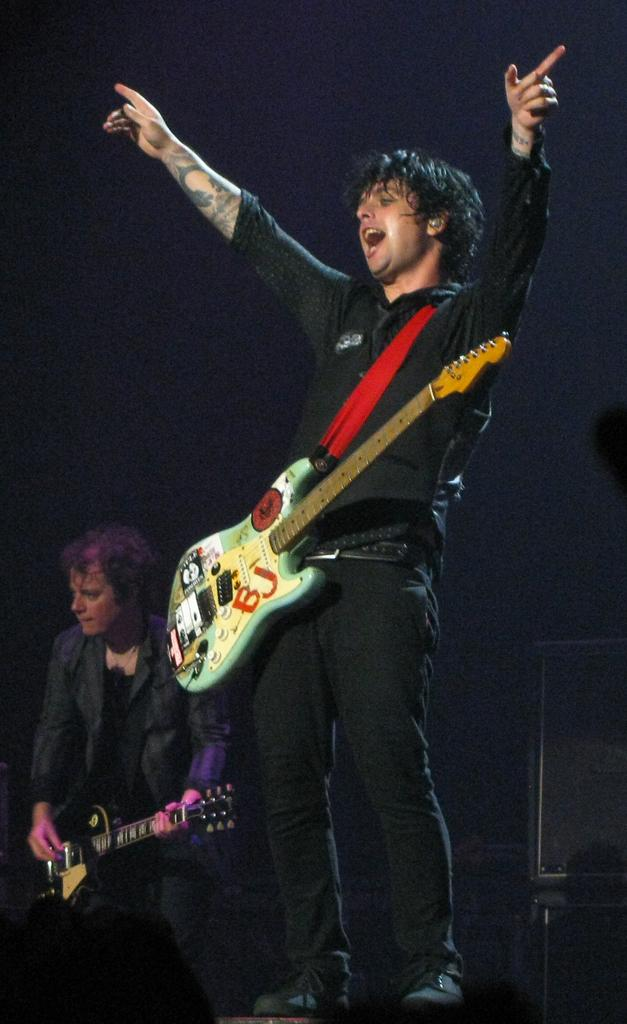How many people are in the image? There are two persons in the image. What are the persons holding in the image? Both persons are holding guitars. What is the person in the back doing with their guitar? The person in the back is playing the guitar. What can be observed about the lighting in the image? The background of the image is dark. What else can be seen in the background of the image? There are objects in the background of the image. What type of army is depicted in the image? There is no army present in the image; it features two persons holding guitars. How many clovers can be seen in the image? There are no clovers present in the image. 